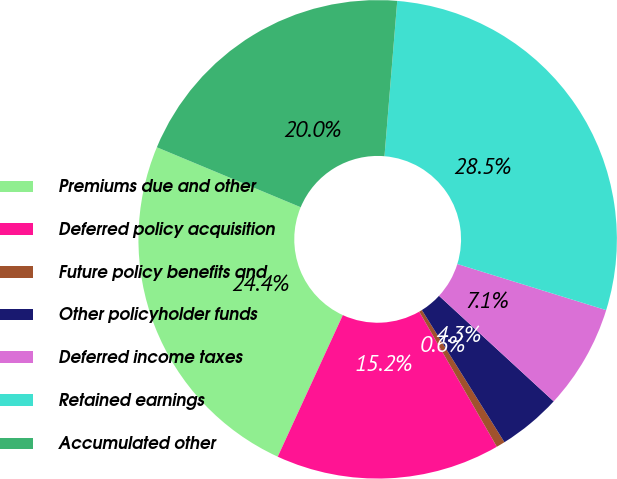Convert chart. <chart><loc_0><loc_0><loc_500><loc_500><pie_chart><fcel>Premiums due and other<fcel>Deferred policy acquisition<fcel>Future policy benefits and<fcel>Other policyholder funds<fcel>Deferred income taxes<fcel>Retained earnings<fcel>Accumulated other<nl><fcel>24.43%<fcel>15.16%<fcel>0.59%<fcel>4.27%<fcel>7.06%<fcel>28.48%<fcel>20.02%<nl></chart> 